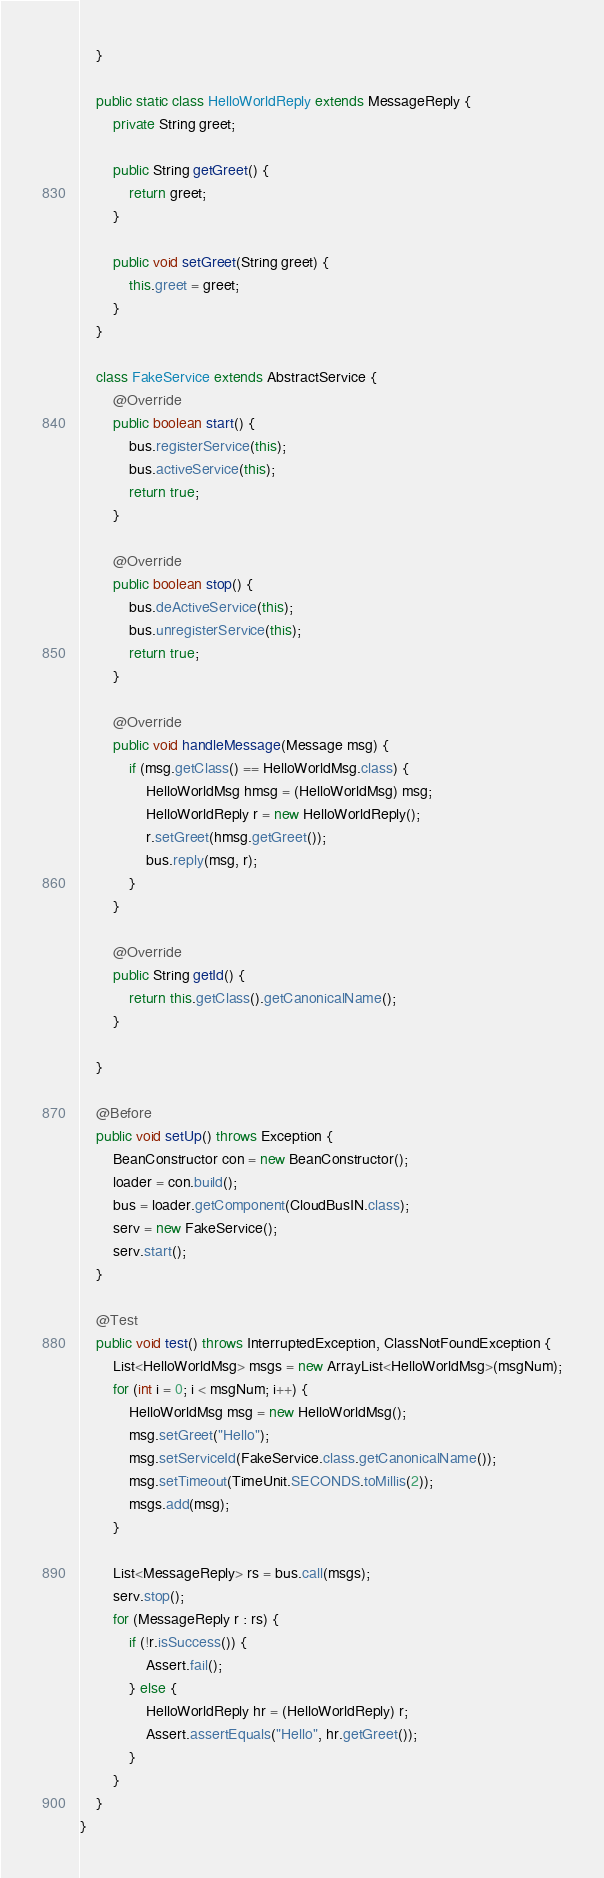Convert code to text. <code><loc_0><loc_0><loc_500><loc_500><_Java_>
    }

    public static class HelloWorldReply extends MessageReply {
        private String greet;

        public String getGreet() {
            return greet;
        }

        public void setGreet(String greet) {
            this.greet = greet;
        }
    }

    class FakeService extends AbstractService {
        @Override
        public boolean start() {
            bus.registerService(this);
            bus.activeService(this);
            return true;
        }

        @Override
        public boolean stop() {
            bus.deActiveService(this);
            bus.unregisterService(this);
            return true;
        }

        @Override
        public void handleMessage(Message msg) {
            if (msg.getClass() == HelloWorldMsg.class) {
                HelloWorldMsg hmsg = (HelloWorldMsg) msg;
                HelloWorldReply r = new HelloWorldReply();
                r.setGreet(hmsg.getGreet());
                bus.reply(msg, r);
            }
        }

        @Override
        public String getId() {
            return this.getClass().getCanonicalName();
        }

    }

    @Before
    public void setUp() throws Exception {
        BeanConstructor con = new BeanConstructor();
        loader = con.build();
        bus = loader.getComponent(CloudBusIN.class);
        serv = new FakeService();
        serv.start();
    }

    @Test
    public void test() throws InterruptedException, ClassNotFoundException {
        List<HelloWorldMsg> msgs = new ArrayList<HelloWorldMsg>(msgNum);
        for (int i = 0; i < msgNum; i++) {
            HelloWorldMsg msg = new HelloWorldMsg();
            msg.setGreet("Hello");
            msg.setServiceId(FakeService.class.getCanonicalName());
            msg.setTimeout(TimeUnit.SECONDS.toMillis(2));
            msgs.add(msg);
        }

        List<MessageReply> rs = bus.call(msgs);
        serv.stop();
        for (MessageReply r : rs) {
            if (!r.isSuccess()) {
                Assert.fail();
            } else {
                HelloWorldReply hr = (HelloWorldReply) r;
                Assert.assertEquals("Hello", hr.getGreet());
            }
        }
    }
}
</code> 